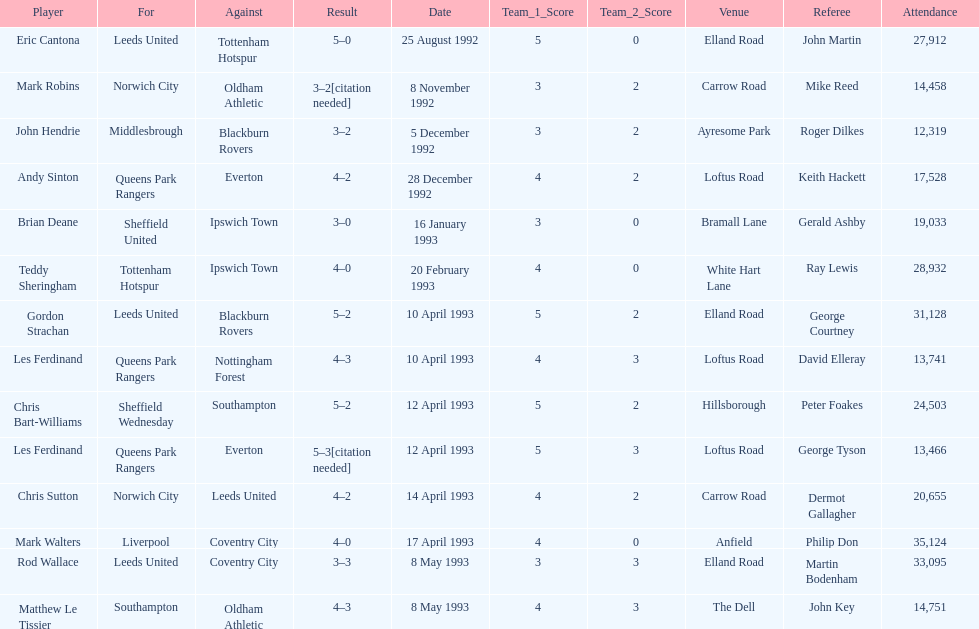Which squad did liverpool compete against? Coventry City. 